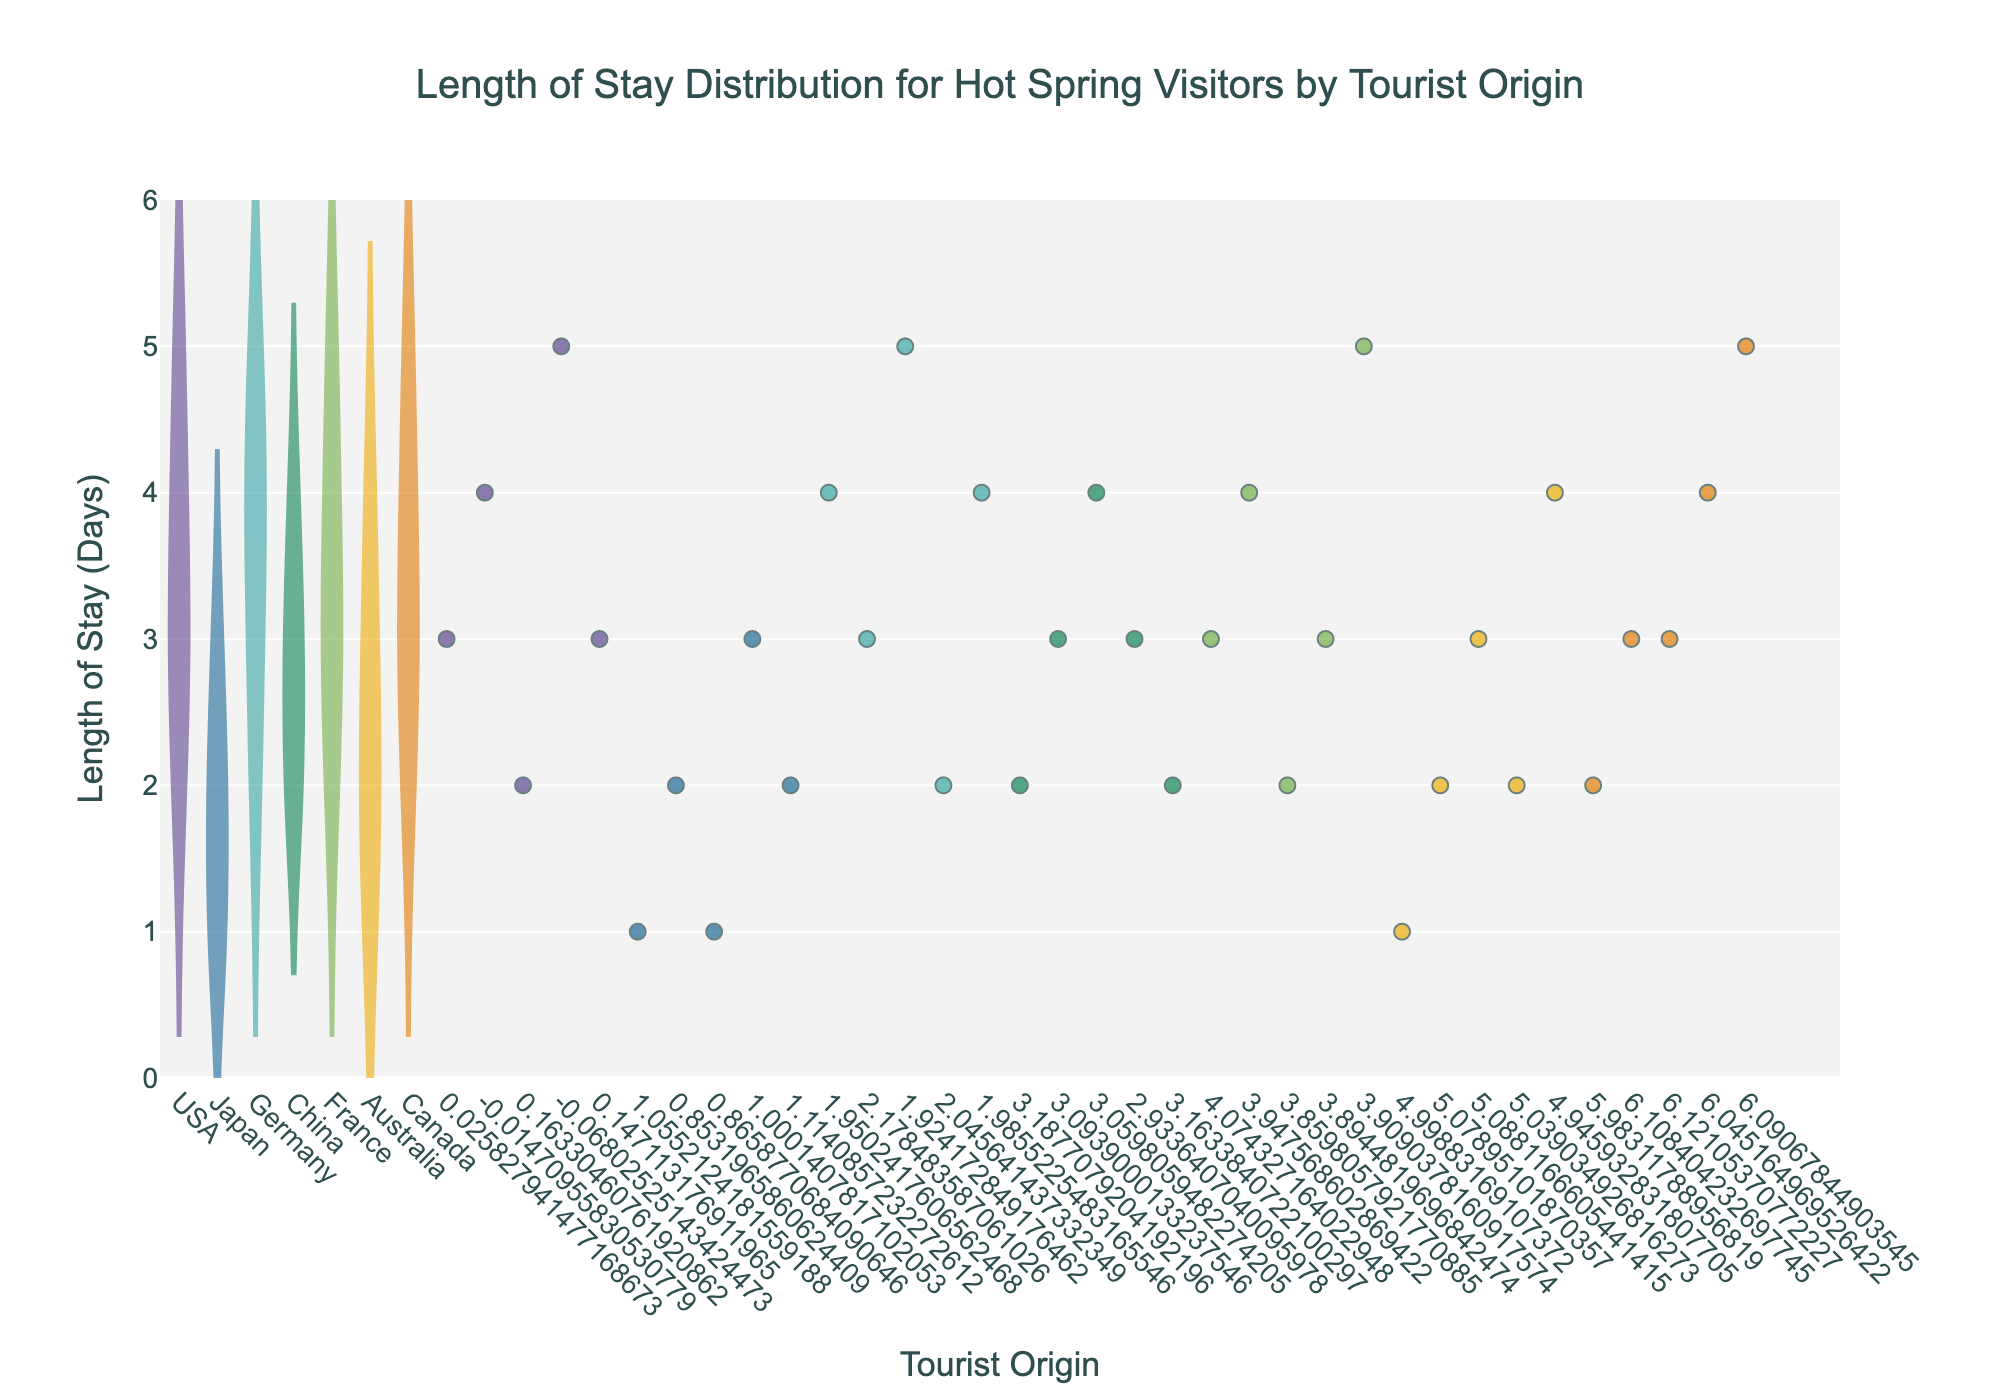What is the title of the figure? The title of the figure can be found at the top of the chart, typically centered and in bold. It provides a clear description of what the figure represents.
Answer: "Length of Stay Distribution for Hot Spring Visitors by Tourist Origin" How many tourist origins are displayed in the chart? Count the unique categories along the x-axis representing different tourist origins.
Answer: 6 Which tourist origin shows the highest median length of stay? The median is represented by the white point on each violin plot. To determine the highest median, compare the positions of these points across different origins.
Answer: Germany How many data points are there for tourists from Japan? Count the number of jittered points overlaying the Japan violin plot.
Answer: 5 What is the range of lengths of stay for tourists from the USA? Observe the span of the USA violin plot from the lowest to the highest data points to determine the range.
Answer: 2 to 5 days Which tourist origins have the same most common length of stay? Identify the peaks of the violin plots. If more than one origin has their peak at the same length of stay, they share a most common length of stay. Compare the shapes of the violin plots to find overlaps.
Answer: USA, China, and France (3 days) Among tourists from Australia and Canada, who has a wider range of stay durations? Compare the spans (from the bottom to the top) of the violin plots for Australia and Canada to see which one covers a broader range of values.
Answer: Canada What is the minimum length of stay observed in the entire chart? Look for the lowest point across all violin plots and jittered points along the y-axis.
Answer: 1 day Between China and France, which country has more visitors staying 4 days? Count the number of jittered points at 4 days within the violin plots for China and France.
Answer: China What is the average length of stay for tourists from Australia? Sum the length of stay values for all points in the Australia violin plot and divide by the number of points. This is found by: (1 + 2 + 3 + 2 + 4) / 5 = 2.4
Answer: 2.4 days 